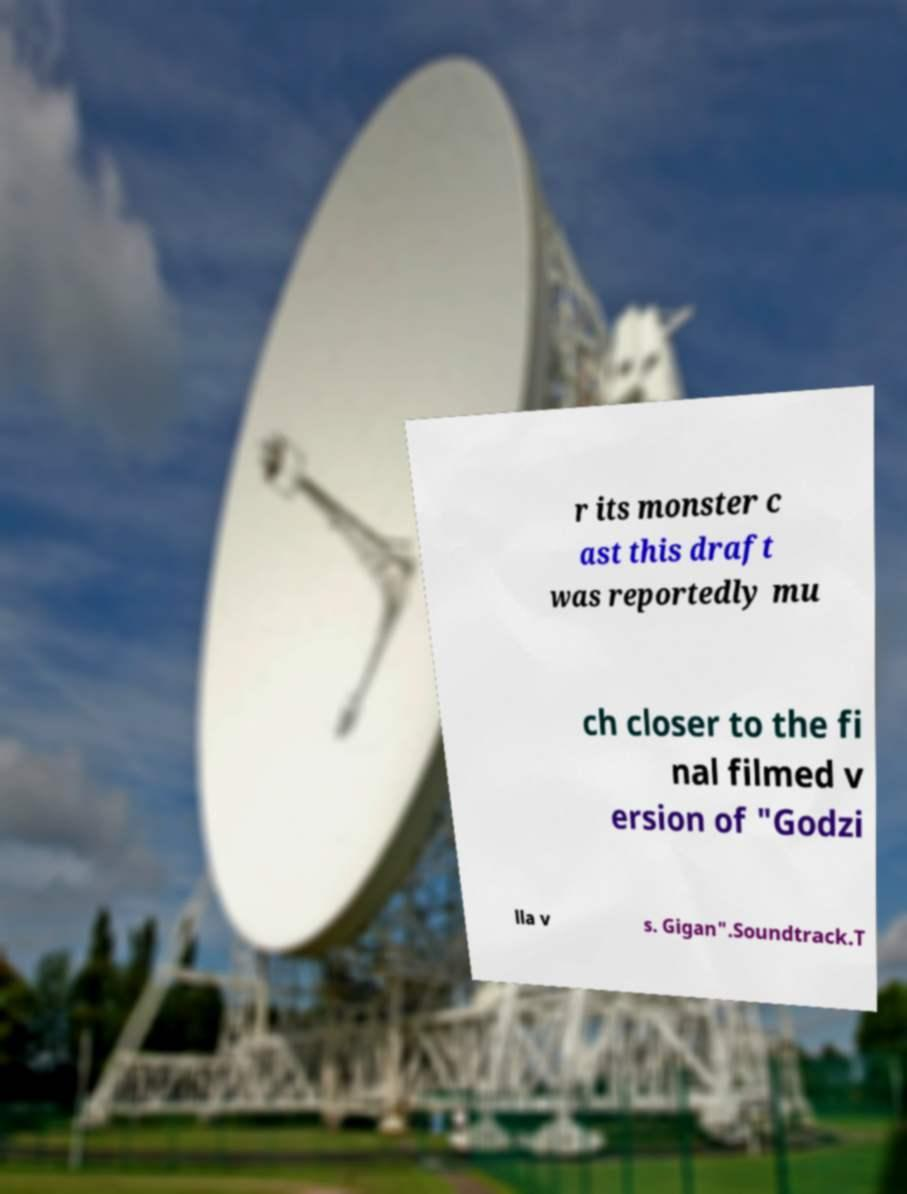For documentation purposes, I need the text within this image transcribed. Could you provide that? r its monster c ast this draft was reportedly mu ch closer to the fi nal filmed v ersion of "Godzi lla v s. Gigan".Soundtrack.T 